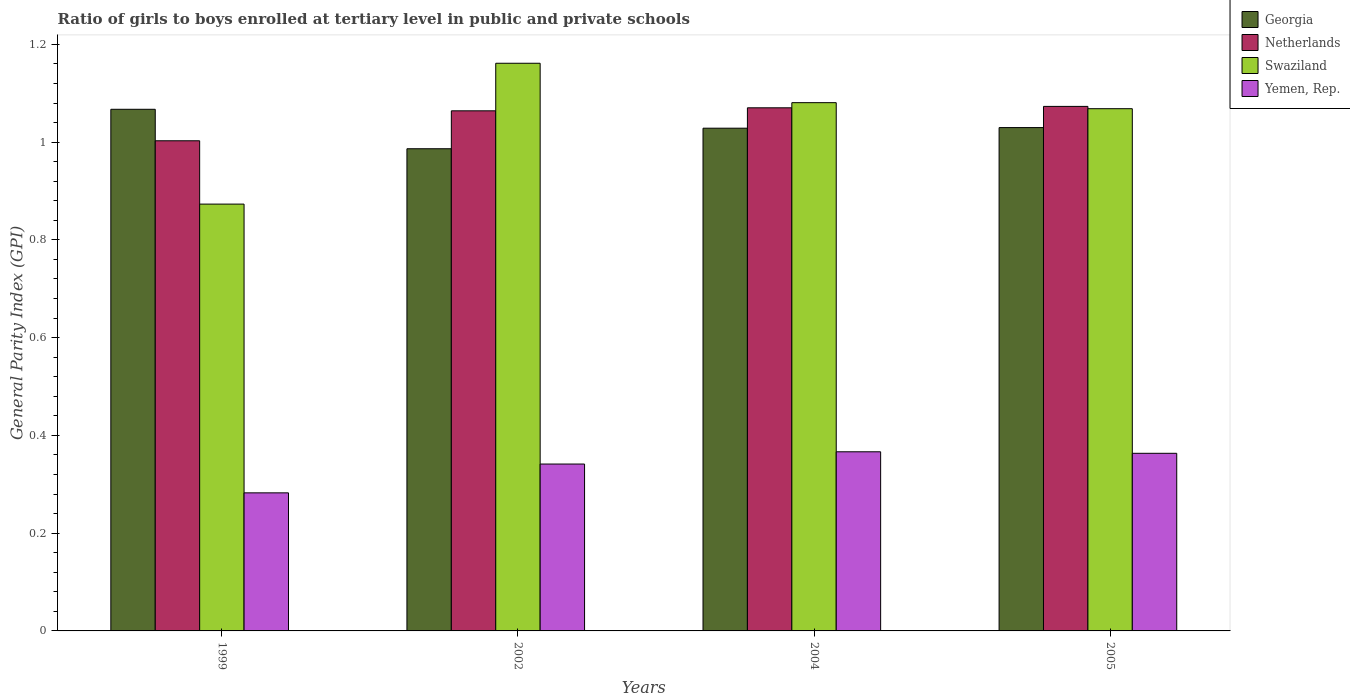How many different coloured bars are there?
Provide a short and direct response. 4. Are the number of bars on each tick of the X-axis equal?
Your response must be concise. Yes. How many bars are there on the 1st tick from the left?
Give a very brief answer. 4. What is the general parity index in Netherlands in 1999?
Keep it short and to the point. 1. Across all years, what is the maximum general parity index in Swaziland?
Give a very brief answer. 1.16. Across all years, what is the minimum general parity index in Georgia?
Your answer should be very brief. 0.99. What is the total general parity index in Georgia in the graph?
Keep it short and to the point. 4.11. What is the difference between the general parity index in Swaziland in 2004 and that in 2005?
Provide a short and direct response. 0.01. What is the difference between the general parity index in Yemen, Rep. in 2005 and the general parity index in Georgia in 2002?
Your answer should be very brief. -0.62. What is the average general parity index in Yemen, Rep. per year?
Your response must be concise. 0.34. In the year 2004, what is the difference between the general parity index in Yemen, Rep. and general parity index in Swaziland?
Your answer should be very brief. -0.71. What is the ratio of the general parity index in Netherlands in 1999 to that in 2004?
Your answer should be very brief. 0.94. Is the general parity index in Swaziland in 1999 less than that in 2004?
Ensure brevity in your answer.  Yes. What is the difference between the highest and the second highest general parity index in Swaziland?
Keep it short and to the point. 0.08. What is the difference between the highest and the lowest general parity index in Swaziland?
Offer a terse response. 0.29. In how many years, is the general parity index in Georgia greater than the average general parity index in Georgia taken over all years?
Give a very brief answer. 3. What does the 1st bar from the right in 2002 represents?
Your response must be concise. Yemen, Rep. How many years are there in the graph?
Offer a terse response. 4. Does the graph contain any zero values?
Your answer should be compact. No. Where does the legend appear in the graph?
Your answer should be compact. Top right. What is the title of the graph?
Offer a terse response. Ratio of girls to boys enrolled at tertiary level in public and private schools. What is the label or title of the X-axis?
Provide a succinct answer. Years. What is the label or title of the Y-axis?
Your answer should be compact. General Parity Index (GPI). What is the General Parity Index (GPI) in Georgia in 1999?
Offer a very short reply. 1.07. What is the General Parity Index (GPI) in Netherlands in 1999?
Your answer should be very brief. 1. What is the General Parity Index (GPI) of Swaziland in 1999?
Your answer should be very brief. 0.87. What is the General Parity Index (GPI) of Yemen, Rep. in 1999?
Give a very brief answer. 0.28. What is the General Parity Index (GPI) in Georgia in 2002?
Ensure brevity in your answer.  0.99. What is the General Parity Index (GPI) in Netherlands in 2002?
Provide a short and direct response. 1.06. What is the General Parity Index (GPI) of Swaziland in 2002?
Ensure brevity in your answer.  1.16. What is the General Parity Index (GPI) of Yemen, Rep. in 2002?
Your answer should be very brief. 0.34. What is the General Parity Index (GPI) of Georgia in 2004?
Provide a short and direct response. 1.03. What is the General Parity Index (GPI) in Netherlands in 2004?
Your response must be concise. 1.07. What is the General Parity Index (GPI) of Swaziland in 2004?
Provide a short and direct response. 1.08. What is the General Parity Index (GPI) of Yemen, Rep. in 2004?
Offer a very short reply. 0.37. What is the General Parity Index (GPI) of Georgia in 2005?
Offer a terse response. 1.03. What is the General Parity Index (GPI) in Netherlands in 2005?
Your answer should be very brief. 1.07. What is the General Parity Index (GPI) in Swaziland in 2005?
Your response must be concise. 1.07. What is the General Parity Index (GPI) of Yemen, Rep. in 2005?
Provide a succinct answer. 0.36. Across all years, what is the maximum General Parity Index (GPI) in Georgia?
Offer a very short reply. 1.07. Across all years, what is the maximum General Parity Index (GPI) in Netherlands?
Give a very brief answer. 1.07. Across all years, what is the maximum General Parity Index (GPI) of Swaziland?
Ensure brevity in your answer.  1.16. Across all years, what is the maximum General Parity Index (GPI) of Yemen, Rep.?
Your answer should be compact. 0.37. Across all years, what is the minimum General Parity Index (GPI) of Georgia?
Make the answer very short. 0.99. Across all years, what is the minimum General Parity Index (GPI) of Netherlands?
Keep it short and to the point. 1. Across all years, what is the minimum General Parity Index (GPI) of Swaziland?
Give a very brief answer. 0.87. Across all years, what is the minimum General Parity Index (GPI) in Yemen, Rep.?
Make the answer very short. 0.28. What is the total General Parity Index (GPI) of Georgia in the graph?
Make the answer very short. 4.11. What is the total General Parity Index (GPI) of Netherlands in the graph?
Provide a succinct answer. 4.21. What is the total General Parity Index (GPI) of Swaziland in the graph?
Offer a terse response. 4.18. What is the total General Parity Index (GPI) of Yemen, Rep. in the graph?
Your answer should be very brief. 1.35. What is the difference between the General Parity Index (GPI) of Georgia in 1999 and that in 2002?
Make the answer very short. 0.08. What is the difference between the General Parity Index (GPI) of Netherlands in 1999 and that in 2002?
Your answer should be compact. -0.06. What is the difference between the General Parity Index (GPI) of Swaziland in 1999 and that in 2002?
Your answer should be very brief. -0.29. What is the difference between the General Parity Index (GPI) in Yemen, Rep. in 1999 and that in 2002?
Offer a terse response. -0.06. What is the difference between the General Parity Index (GPI) of Georgia in 1999 and that in 2004?
Make the answer very short. 0.04. What is the difference between the General Parity Index (GPI) in Netherlands in 1999 and that in 2004?
Offer a very short reply. -0.07. What is the difference between the General Parity Index (GPI) of Swaziland in 1999 and that in 2004?
Your response must be concise. -0.21. What is the difference between the General Parity Index (GPI) of Yemen, Rep. in 1999 and that in 2004?
Offer a terse response. -0.08. What is the difference between the General Parity Index (GPI) in Georgia in 1999 and that in 2005?
Keep it short and to the point. 0.04. What is the difference between the General Parity Index (GPI) in Netherlands in 1999 and that in 2005?
Keep it short and to the point. -0.07. What is the difference between the General Parity Index (GPI) in Swaziland in 1999 and that in 2005?
Provide a succinct answer. -0.2. What is the difference between the General Parity Index (GPI) of Yemen, Rep. in 1999 and that in 2005?
Offer a terse response. -0.08. What is the difference between the General Parity Index (GPI) in Georgia in 2002 and that in 2004?
Provide a short and direct response. -0.04. What is the difference between the General Parity Index (GPI) in Netherlands in 2002 and that in 2004?
Give a very brief answer. -0.01. What is the difference between the General Parity Index (GPI) in Swaziland in 2002 and that in 2004?
Make the answer very short. 0.08. What is the difference between the General Parity Index (GPI) of Yemen, Rep. in 2002 and that in 2004?
Offer a terse response. -0.03. What is the difference between the General Parity Index (GPI) in Georgia in 2002 and that in 2005?
Give a very brief answer. -0.04. What is the difference between the General Parity Index (GPI) in Netherlands in 2002 and that in 2005?
Give a very brief answer. -0.01. What is the difference between the General Parity Index (GPI) of Swaziland in 2002 and that in 2005?
Your response must be concise. 0.09. What is the difference between the General Parity Index (GPI) in Yemen, Rep. in 2002 and that in 2005?
Your answer should be very brief. -0.02. What is the difference between the General Parity Index (GPI) in Georgia in 2004 and that in 2005?
Keep it short and to the point. -0. What is the difference between the General Parity Index (GPI) of Netherlands in 2004 and that in 2005?
Your answer should be compact. -0. What is the difference between the General Parity Index (GPI) of Swaziland in 2004 and that in 2005?
Offer a very short reply. 0.01. What is the difference between the General Parity Index (GPI) in Yemen, Rep. in 2004 and that in 2005?
Your answer should be compact. 0. What is the difference between the General Parity Index (GPI) in Georgia in 1999 and the General Parity Index (GPI) in Netherlands in 2002?
Make the answer very short. 0. What is the difference between the General Parity Index (GPI) in Georgia in 1999 and the General Parity Index (GPI) in Swaziland in 2002?
Ensure brevity in your answer.  -0.09. What is the difference between the General Parity Index (GPI) in Georgia in 1999 and the General Parity Index (GPI) in Yemen, Rep. in 2002?
Your answer should be compact. 0.73. What is the difference between the General Parity Index (GPI) in Netherlands in 1999 and the General Parity Index (GPI) in Swaziland in 2002?
Make the answer very short. -0.16. What is the difference between the General Parity Index (GPI) of Netherlands in 1999 and the General Parity Index (GPI) of Yemen, Rep. in 2002?
Give a very brief answer. 0.66. What is the difference between the General Parity Index (GPI) of Swaziland in 1999 and the General Parity Index (GPI) of Yemen, Rep. in 2002?
Provide a short and direct response. 0.53. What is the difference between the General Parity Index (GPI) in Georgia in 1999 and the General Parity Index (GPI) in Netherlands in 2004?
Keep it short and to the point. -0. What is the difference between the General Parity Index (GPI) of Georgia in 1999 and the General Parity Index (GPI) of Swaziland in 2004?
Your answer should be compact. -0.01. What is the difference between the General Parity Index (GPI) in Georgia in 1999 and the General Parity Index (GPI) in Yemen, Rep. in 2004?
Provide a succinct answer. 0.7. What is the difference between the General Parity Index (GPI) in Netherlands in 1999 and the General Parity Index (GPI) in Swaziland in 2004?
Your answer should be very brief. -0.08. What is the difference between the General Parity Index (GPI) in Netherlands in 1999 and the General Parity Index (GPI) in Yemen, Rep. in 2004?
Your answer should be very brief. 0.64. What is the difference between the General Parity Index (GPI) of Swaziland in 1999 and the General Parity Index (GPI) of Yemen, Rep. in 2004?
Provide a succinct answer. 0.51. What is the difference between the General Parity Index (GPI) in Georgia in 1999 and the General Parity Index (GPI) in Netherlands in 2005?
Your answer should be very brief. -0.01. What is the difference between the General Parity Index (GPI) of Georgia in 1999 and the General Parity Index (GPI) of Swaziland in 2005?
Your answer should be compact. -0. What is the difference between the General Parity Index (GPI) of Georgia in 1999 and the General Parity Index (GPI) of Yemen, Rep. in 2005?
Ensure brevity in your answer.  0.7. What is the difference between the General Parity Index (GPI) in Netherlands in 1999 and the General Parity Index (GPI) in Swaziland in 2005?
Provide a succinct answer. -0.07. What is the difference between the General Parity Index (GPI) in Netherlands in 1999 and the General Parity Index (GPI) in Yemen, Rep. in 2005?
Offer a very short reply. 0.64. What is the difference between the General Parity Index (GPI) in Swaziland in 1999 and the General Parity Index (GPI) in Yemen, Rep. in 2005?
Your answer should be very brief. 0.51. What is the difference between the General Parity Index (GPI) in Georgia in 2002 and the General Parity Index (GPI) in Netherlands in 2004?
Provide a short and direct response. -0.08. What is the difference between the General Parity Index (GPI) in Georgia in 2002 and the General Parity Index (GPI) in Swaziland in 2004?
Provide a short and direct response. -0.09. What is the difference between the General Parity Index (GPI) in Georgia in 2002 and the General Parity Index (GPI) in Yemen, Rep. in 2004?
Give a very brief answer. 0.62. What is the difference between the General Parity Index (GPI) of Netherlands in 2002 and the General Parity Index (GPI) of Swaziland in 2004?
Offer a very short reply. -0.02. What is the difference between the General Parity Index (GPI) of Netherlands in 2002 and the General Parity Index (GPI) of Yemen, Rep. in 2004?
Keep it short and to the point. 0.7. What is the difference between the General Parity Index (GPI) of Swaziland in 2002 and the General Parity Index (GPI) of Yemen, Rep. in 2004?
Keep it short and to the point. 0.79. What is the difference between the General Parity Index (GPI) of Georgia in 2002 and the General Parity Index (GPI) of Netherlands in 2005?
Your answer should be very brief. -0.09. What is the difference between the General Parity Index (GPI) in Georgia in 2002 and the General Parity Index (GPI) in Swaziland in 2005?
Your answer should be very brief. -0.08. What is the difference between the General Parity Index (GPI) of Georgia in 2002 and the General Parity Index (GPI) of Yemen, Rep. in 2005?
Your response must be concise. 0.62. What is the difference between the General Parity Index (GPI) in Netherlands in 2002 and the General Parity Index (GPI) in Swaziland in 2005?
Offer a terse response. -0. What is the difference between the General Parity Index (GPI) of Netherlands in 2002 and the General Parity Index (GPI) of Yemen, Rep. in 2005?
Your response must be concise. 0.7. What is the difference between the General Parity Index (GPI) of Swaziland in 2002 and the General Parity Index (GPI) of Yemen, Rep. in 2005?
Provide a short and direct response. 0.8. What is the difference between the General Parity Index (GPI) in Georgia in 2004 and the General Parity Index (GPI) in Netherlands in 2005?
Your answer should be compact. -0.04. What is the difference between the General Parity Index (GPI) of Georgia in 2004 and the General Parity Index (GPI) of Swaziland in 2005?
Make the answer very short. -0.04. What is the difference between the General Parity Index (GPI) in Georgia in 2004 and the General Parity Index (GPI) in Yemen, Rep. in 2005?
Ensure brevity in your answer.  0.67. What is the difference between the General Parity Index (GPI) of Netherlands in 2004 and the General Parity Index (GPI) of Swaziland in 2005?
Offer a very short reply. 0. What is the difference between the General Parity Index (GPI) in Netherlands in 2004 and the General Parity Index (GPI) in Yemen, Rep. in 2005?
Make the answer very short. 0.71. What is the difference between the General Parity Index (GPI) in Swaziland in 2004 and the General Parity Index (GPI) in Yemen, Rep. in 2005?
Your response must be concise. 0.72. What is the average General Parity Index (GPI) of Georgia per year?
Your response must be concise. 1.03. What is the average General Parity Index (GPI) of Netherlands per year?
Your answer should be compact. 1.05. What is the average General Parity Index (GPI) of Swaziland per year?
Provide a succinct answer. 1.05. What is the average General Parity Index (GPI) of Yemen, Rep. per year?
Your answer should be very brief. 0.34. In the year 1999, what is the difference between the General Parity Index (GPI) in Georgia and General Parity Index (GPI) in Netherlands?
Your answer should be compact. 0.06. In the year 1999, what is the difference between the General Parity Index (GPI) in Georgia and General Parity Index (GPI) in Swaziland?
Provide a short and direct response. 0.19. In the year 1999, what is the difference between the General Parity Index (GPI) in Georgia and General Parity Index (GPI) in Yemen, Rep.?
Offer a very short reply. 0.78. In the year 1999, what is the difference between the General Parity Index (GPI) in Netherlands and General Parity Index (GPI) in Swaziland?
Provide a short and direct response. 0.13. In the year 1999, what is the difference between the General Parity Index (GPI) in Netherlands and General Parity Index (GPI) in Yemen, Rep.?
Offer a terse response. 0.72. In the year 1999, what is the difference between the General Parity Index (GPI) in Swaziland and General Parity Index (GPI) in Yemen, Rep.?
Offer a very short reply. 0.59. In the year 2002, what is the difference between the General Parity Index (GPI) in Georgia and General Parity Index (GPI) in Netherlands?
Your response must be concise. -0.08. In the year 2002, what is the difference between the General Parity Index (GPI) of Georgia and General Parity Index (GPI) of Swaziland?
Keep it short and to the point. -0.17. In the year 2002, what is the difference between the General Parity Index (GPI) of Georgia and General Parity Index (GPI) of Yemen, Rep.?
Provide a succinct answer. 0.65. In the year 2002, what is the difference between the General Parity Index (GPI) of Netherlands and General Parity Index (GPI) of Swaziland?
Your answer should be compact. -0.1. In the year 2002, what is the difference between the General Parity Index (GPI) of Netherlands and General Parity Index (GPI) of Yemen, Rep.?
Your answer should be compact. 0.72. In the year 2002, what is the difference between the General Parity Index (GPI) in Swaziland and General Parity Index (GPI) in Yemen, Rep.?
Provide a short and direct response. 0.82. In the year 2004, what is the difference between the General Parity Index (GPI) in Georgia and General Parity Index (GPI) in Netherlands?
Your answer should be very brief. -0.04. In the year 2004, what is the difference between the General Parity Index (GPI) in Georgia and General Parity Index (GPI) in Swaziland?
Offer a terse response. -0.05. In the year 2004, what is the difference between the General Parity Index (GPI) in Georgia and General Parity Index (GPI) in Yemen, Rep.?
Offer a terse response. 0.66. In the year 2004, what is the difference between the General Parity Index (GPI) in Netherlands and General Parity Index (GPI) in Swaziland?
Give a very brief answer. -0.01. In the year 2004, what is the difference between the General Parity Index (GPI) of Netherlands and General Parity Index (GPI) of Yemen, Rep.?
Make the answer very short. 0.7. In the year 2004, what is the difference between the General Parity Index (GPI) in Swaziland and General Parity Index (GPI) in Yemen, Rep.?
Offer a very short reply. 0.71. In the year 2005, what is the difference between the General Parity Index (GPI) of Georgia and General Parity Index (GPI) of Netherlands?
Provide a succinct answer. -0.04. In the year 2005, what is the difference between the General Parity Index (GPI) of Georgia and General Parity Index (GPI) of Swaziland?
Make the answer very short. -0.04. In the year 2005, what is the difference between the General Parity Index (GPI) in Georgia and General Parity Index (GPI) in Yemen, Rep.?
Ensure brevity in your answer.  0.67. In the year 2005, what is the difference between the General Parity Index (GPI) of Netherlands and General Parity Index (GPI) of Swaziland?
Offer a terse response. 0. In the year 2005, what is the difference between the General Parity Index (GPI) of Netherlands and General Parity Index (GPI) of Yemen, Rep.?
Your answer should be very brief. 0.71. In the year 2005, what is the difference between the General Parity Index (GPI) in Swaziland and General Parity Index (GPI) in Yemen, Rep.?
Your answer should be very brief. 0.7. What is the ratio of the General Parity Index (GPI) of Georgia in 1999 to that in 2002?
Make the answer very short. 1.08. What is the ratio of the General Parity Index (GPI) of Netherlands in 1999 to that in 2002?
Provide a succinct answer. 0.94. What is the ratio of the General Parity Index (GPI) in Swaziland in 1999 to that in 2002?
Offer a terse response. 0.75. What is the ratio of the General Parity Index (GPI) of Yemen, Rep. in 1999 to that in 2002?
Ensure brevity in your answer.  0.83. What is the ratio of the General Parity Index (GPI) in Georgia in 1999 to that in 2004?
Your answer should be very brief. 1.04. What is the ratio of the General Parity Index (GPI) in Netherlands in 1999 to that in 2004?
Your answer should be compact. 0.94. What is the ratio of the General Parity Index (GPI) of Swaziland in 1999 to that in 2004?
Offer a very short reply. 0.81. What is the ratio of the General Parity Index (GPI) of Yemen, Rep. in 1999 to that in 2004?
Your answer should be compact. 0.77. What is the ratio of the General Parity Index (GPI) in Georgia in 1999 to that in 2005?
Keep it short and to the point. 1.04. What is the ratio of the General Parity Index (GPI) of Netherlands in 1999 to that in 2005?
Provide a short and direct response. 0.93. What is the ratio of the General Parity Index (GPI) in Swaziland in 1999 to that in 2005?
Your answer should be compact. 0.82. What is the ratio of the General Parity Index (GPI) in Yemen, Rep. in 1999 to that in 2005?
Ensure brevity in your answer.  0.78. What is the ratio of the General Parity Index (GPI) in Georgia in 2002 to that in 2004?
Your answer should be compact. 0.96. What is the ratio of the General Parity Index (GPI) of Netherlands in 2002 to that in 2004?
Offer a very short reply. 0.99. What is the ratio of the General Parity Index (GPI) of Swaziland in 2002 to that in 2004?
Your response must be concise. 1.07. What is the ratio of the General Parity Index (GPI) in Yemen, Rep. in 2002 to that in 2004?
Offer a very short reply. 0.93. What is the ratio of the General Parity Index (GPI) of Georgia in 2002 to that in 2005?
Offer a terse response. 0.96. What is the ratio of the General Parity Index (GPI) of Swaziland in 2002 to that in 2005?
Your response must be concise. 1.09. What is the ratio of the General Parity Index (GPI) of Yemen, Rep. in 2002 to that in 2005?
Offer a terse response. 0.94. What is the ratio of the General Parity Index (GPI) in Georgia in 2004 to that in 2005?
Keep it short and to the point. 1. What is the ratio of the General Parity Index (GPI) of Swaziland in 2004 to that in 2005?
Your answer should be very brief. 1.01. What is the ratio of the General Parity Index (GPI) of Yemen, Rep. in 2004 to that in 2005?
Give a very brief answer. 1.01. What is the difference between the highest and the second highest General Parity Index (GPI) of Georgia?
Offer a very short reply. 0.04. What is the difference between the highest and the second highest General Parity Index (GPI) in Netherlands?
Your response must be concise. 0. What is the difference between the highest and the second highest General Parity Index (GPI) of Swaziland?
Your answer should be very brief. 0.08. What is the difference between the highest and the second highest General Parity Index (GPI) in Yemen, Rep.?
Keep it short and to the point. 0. What is the difference between the highest and the lowest General Parity Index (GPI) in Georgia?
Give a very brief answer. 0.08. What is the difference between the highest and the lowest General Parity Index (GPI) in Netherlands?
Your response must be concise. 0.07. What is the difference between the highest and the lowest General Parity Index (GPI) of Swaziland?
Make the answer very short. 0.29. What is the difference between the highest and the lowest General Parity Index (GPI) in Yemen, Rep.?
Your answer should be very brief. 0.08. 